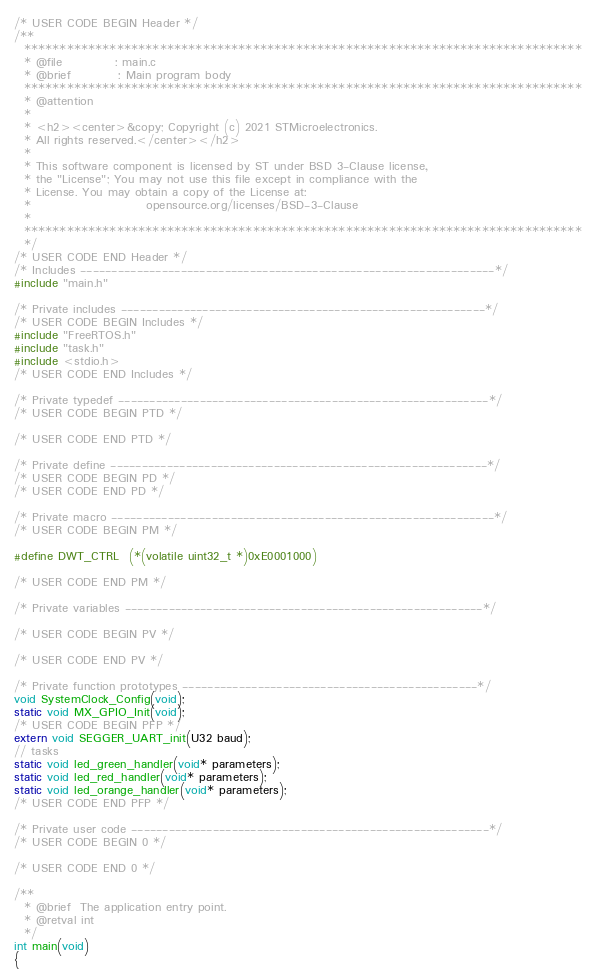Convert code to text. <code><loc_0><loc_0><loc_500><loc_500><_C_>/* USER CODE BEGIN Header */
/**
  ******************************************************************************
  * @file           : main.c
  * @brief          : Main program body
  ******************************************************************************
  * @attention
  *
  * <h2><center>&copy; Copyright (c) 2021 STMicroelectronics.
  * All rights reserved.</center></h2>
  *
  * This software component is licensed by ST under BSD 3-Clause license,
  * the "License"; You may not use this file except in compliance with the
  * License. You may obtain a copy of the License at:
  *                        opensource.org/licenses/BSD-3-Clause
  *
  ******************************************************************************
  */
/* USER CODE END Header */
/* Includes ------------------------------------------------------------------*/
#include "main.h"

/* Private includes ----------------------------------------------------------*/
/* USER CODE BEGIN Includes */
#include "FreeRTOS.h"
#include "task.h"
#include <stdio.h>
/* USER CODE END Includes */

/* Private typedef -----------------------------------------------------------*/
/* USER CODE BEGIN PTD */

/* USER CODE END PTD */

/* Private define ------------------------------------------------------------*/
/* USER CODE BEGIN PD */
/* USER CODE END PD */

/* Private macro -------------------------------------------------------------*/
/* USER CODE BEGIN PM */

#define DWT_CTRL  (*(volatile uint32_t *)0xE0001000)

/* USER CODE END PM */

/* Private variables ---------------------------------------------------------*/

/* USER CODE BEGIN PV */

/* USER CODE END PV */

/* Private function prototypes -----------------------------------------------*/
void SystemClock_Config(void);
static void MX_GPIO_Init(void);
/* USER CODE BEGIN PFP */
extern void SEGGER_UART_init(U32 baud);
// tasks
static void led_green_handler(void* parameters);
static void led_red_handler(void* parameters);
static void led_orange_handler(void* parameters);
/* USER CODE END PFP */

/* Private user code ---------------------------------------------------------*/
/* USER CODE BEGIN 0 */

/* USER CODE END 0 */

/**
  * @brief  The application entry point.
  * @retval int
  */
int main(void)
{</code> 